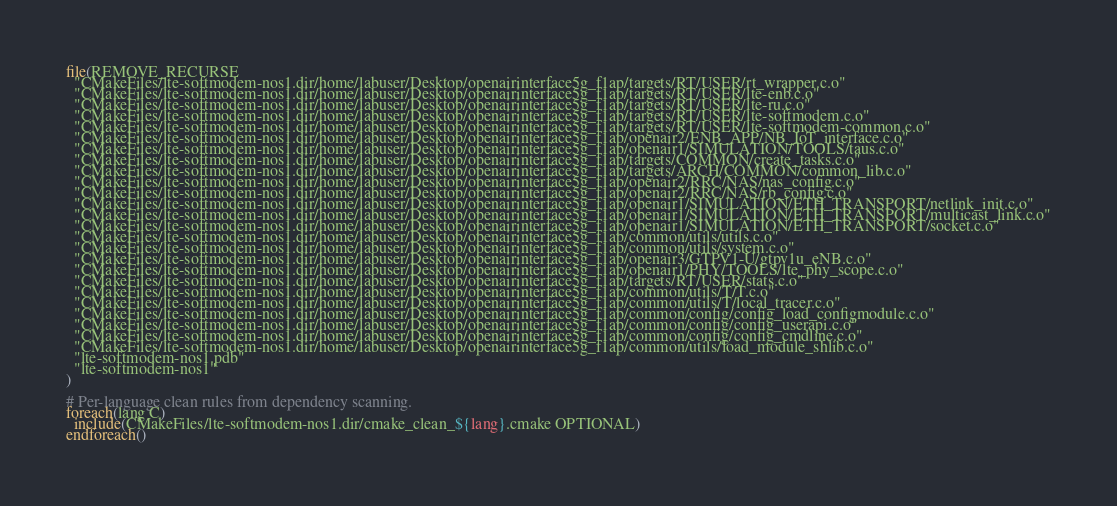<code> <loc_0><loc_0><loc_500><loc_500><_CMake_>file(REMOVE_RECURSE
  "CMakeFiles/lte-softmodem-nos1.dir/home/labuser/Desktop/openairinterface5g_f1ap/targets/RT/USER/rt_wrapper.c.o"
  "CMakeFiles/lte-softmodem-nos1.dir/home/labuser/Desktop/openairinterface5g_f1ap/targets/RT/USER/lte-enb.c.o"
  "CMakeFiles/lte-softmodem-nos1.dir/home/labuser/Desktop/openairinterface5g_f1ap/targets/RT/USER/lte-ru.c.o"
  "CMakeFiles/lte-softmodem-nos1.dir/home/labuser/Desktop/openairinterface5g_f1ap/targets/RT/USER/lte-softmodem.c.o"
  "CMakeFiles/lte-softmodem-nos1.dir/home/labuser/Desktop/openairinterface5g_f1ap/targets/RT/USER/lte-softmodem-common.c.o"
  "CMakeFiles/lte-softmodem-nos1.dir/home/labuser/Desktop/openairinterface5g_f1ap/openair2/ENB_APP/NB_IoT_interface.c.o"
  "CMakeFiles/lte-softmodem-nos1.dir/home/labuser/Desktop/openairinterface5g_f1ap/openair1/SIMULATION/TOOLS/taus.c.o"
  "CMakeFiles/lte-softmodem-nos1.dir/home/labuser/Desktop/openairinterface5g_f1ap/targets/COMMON/create_tasks.c.o"
  "CMakeFiles/lte-softmodem-nos1.dir/home/labuser/Desktop/openairinterface5g_f1ap/targets/ARCH/COMMON/common_lib.c.o"
  "CMakeFiles/lte-softmodem-nos1.dir/home/labuser/Desktop/openairinterface5g_f1ap/openair2/RRC/NAS/nas_config.c.o"
  "CMakeFiles/lte-softmodem-nos1.dir/home/labuser/Desktop/openairinterface5g_f1ap/openair2/RRC/NAS/rb_config.c.o"
  "CMakeFiles/lte-softmodem-nos1.dir/home/labuser/Desktop/openairinterface5g_f1ap/openair1/SIMULATION/ETH_TRANSPORT/netlink_init.c.o"
  "CMakeFiles/lte-softmodem-nos1.dir/home/labuser/Desktop/openairinterface5g_f1ap/openair1/SIMULATION/ETH_TRANSPORT/multicast_link.c.o"
  "CMakeFiles/lte-softmodem-nos1.dir/home/labuser/Desktop/openairinterface5g_f1ap/openair1/SIMULATION/ETH_TRANSPORT/socket.c.o"
  "CMakeFiles/lte-softmodem-nos1.dir/home/labuser/Desktop/openairinterface5g_f1ap/common/utils/utils.c.o"
  "CMakeFiles/lte-softmodem-nos1.dir/home/labuser/Desktop/openairinterface5g_f1ap/common/utils/system.c.o"
  "CMakeFiles/lte-softmodem-nos1.dir/home/labuser/Desktop/openairinterface5g_f1ap/openair3/GTPV1-U/gtpv1u_eNB.c.o"
  "CMakeFiles/lte-softmodem-nos1.dir/home/labuser/Desktop/openairinterface5g_f1ap/openair1/PHY/TOOLS/lte_phy_scope.c.o"
  "CMakeFiles/lte-softmodem-nos1.dir/home/labuser/Desktop/openairinterface5g_f1ap/targets/RT/USER/stats.c.o"
  "CMakeFiles/lte-softmodem-nos1.dir/home/labuser/Desktop/openairinterface5g_f1ap/common/utils/T/T.c.o"
  "CMakeFiles/lte-softmodem-nos1.dir/home/labuser/Desktop/openairinterface5g_f1ap/common/utils/T/local_tracer.c.o"
  "CMakeFiles/lte-softmodem-nos1.dir/home/labuser/Desktop/openairinterface5g_f1ap/common/config/config_load_configmodule.c.o"
  "CMakeFiles/lte-softmodem-nos1.dir/home/labuser/Desktop/openairinterface5g_f1ap/common/config/config_userapi.c.o"
  "CMakeFiles/lte-softmodem-nos1.dir/home/labuser/Desktop/openairinterface5g_f1ap/common/config/config_cmdline.c.o"
  "CMakeFiles/lte-softmodem-nos1.dir/home/labuser/Desktop/openairinterface5g_f1ap/common/utils/load_module_shlib.c.o"
  "lte-softmodem-nos1.pdb"
  "lte-softmodem-nos1"
)

# Per-language clean rules from dependency scanning.
foreach(lang C)
  include(CMakeFiles/lte-softmodem-nos1.dir/cmake_clean_${lang}.cmake OPTIONAL)
endforeach()
</code> 